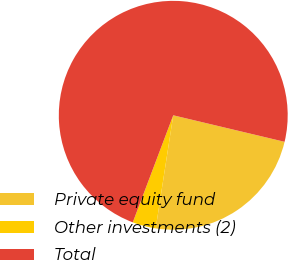Convert chart. <chart><loc_0><loc_0><loc_500><loc_500><pie_chart><fcel>Private equity fund<fcel>Other investments (2)<fcel>Total<nl><fcel>23.73%<fcel>3.3%<fcel>72.97%<nl></chart> 